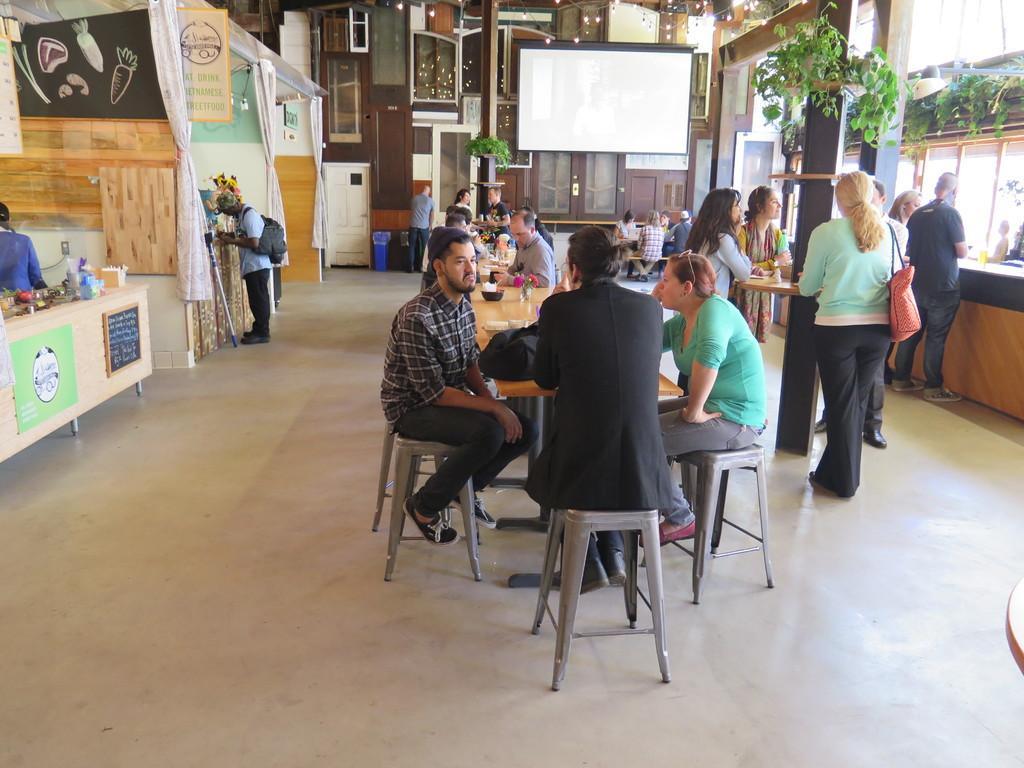Please provide a concise description of this image. In the middle there is a table on that there is a bowl,plate and some other items. In the middle there is a man he wear suit,trouser and shoes. On the right there are many people standing. On the right there is a plant. On the left there is a man he wear check shirt , trouser and shoes. In the background there is a white screen ,window and door. I think this is a restaurant. 